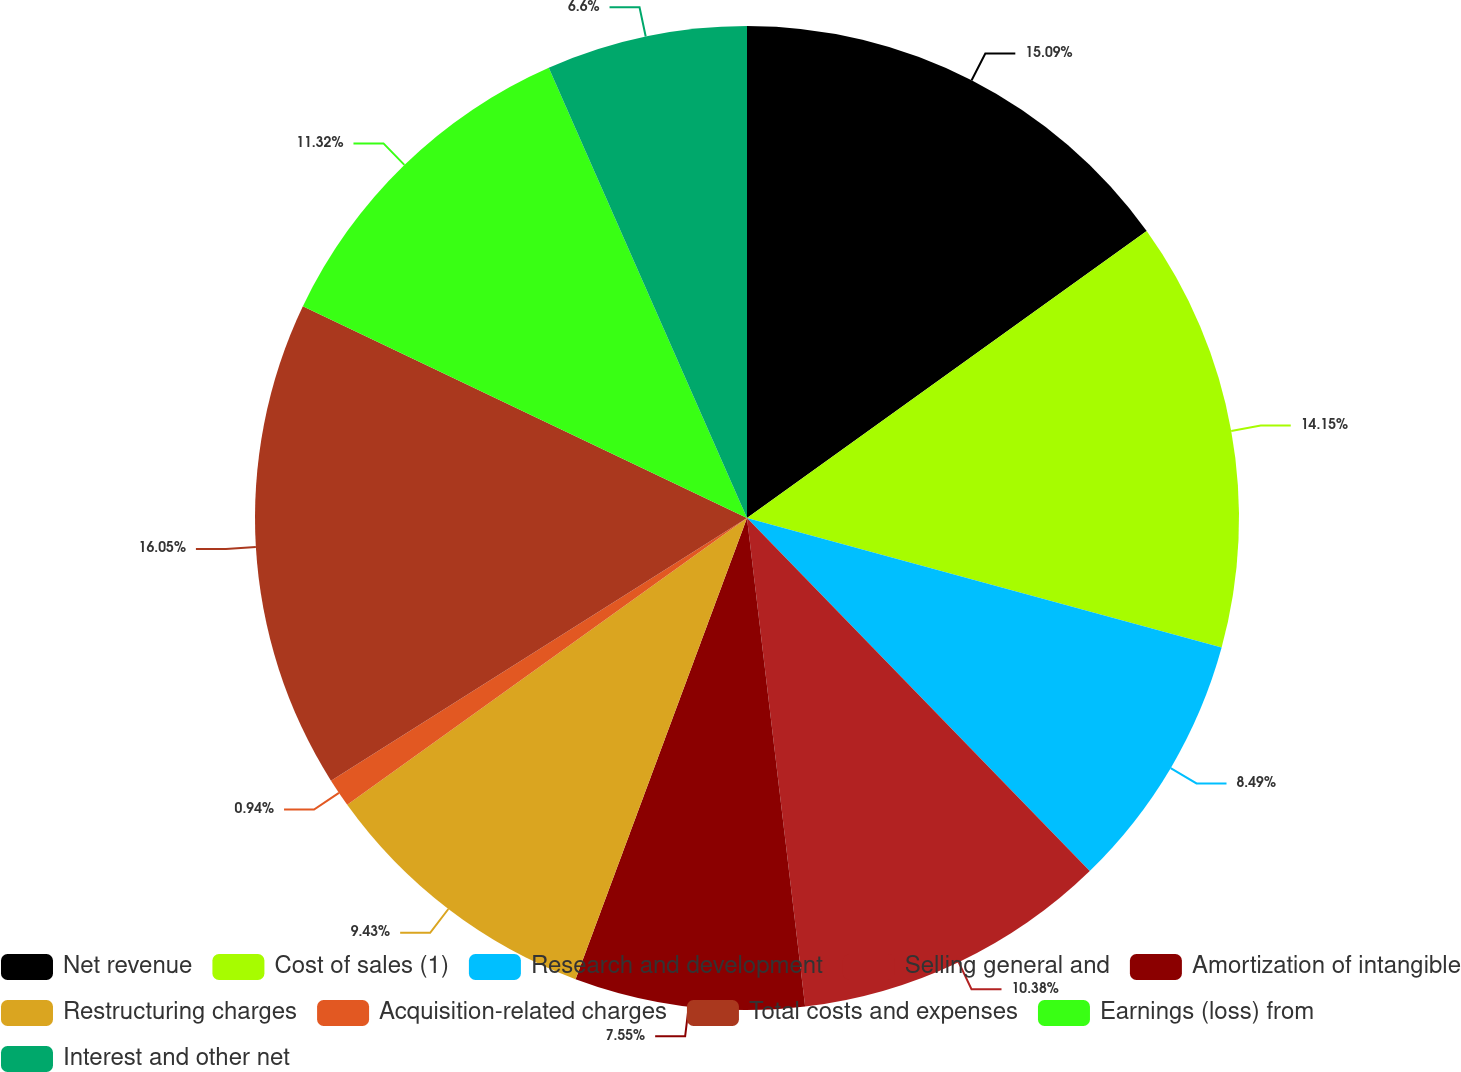<chart> <loc_0><loc_0><loc_500><loc_500><pie_chart><fcel>Net revenue<fcel>Cost of sales (1)<fcel>Research and development<fcel>Selling general and<fcel>Amortization of intangible<fcel>Restructuring charges<fcel>Acquisition-related charges<fcel>Total costs and expenses<fcel>Earnings (loss) from<fcel>Interest and other net<nl><fcel>15.09%<fcel>14.15%<fcel>8.49%<fcel>10.38%<fcel>7.55%<fcel>9.43%<fcel>0.94%<fcel>16.04%<fcel>11.32%<fcel>6.6%<nl></chart> 